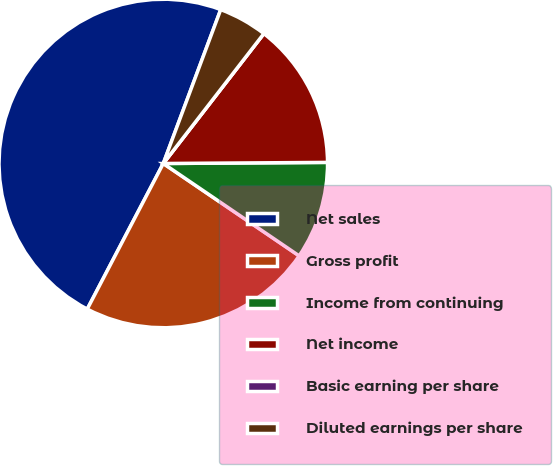Convert chart to OTSL. <chart><loc_0><loc_0><loc_500><loc_500><pie_chart><fcel>Net sales<fcel>Gross profit<fcel>Income from continuing<fcel>Net income<fcel>Basic earning per share<fcel>Diluted earnings per share<nl><fcel>48.03%<fcel>23.16%<fcel>9.61%<fcel>14.41%<fcel>0.0%<fcel>4.8%<nl></chart> 